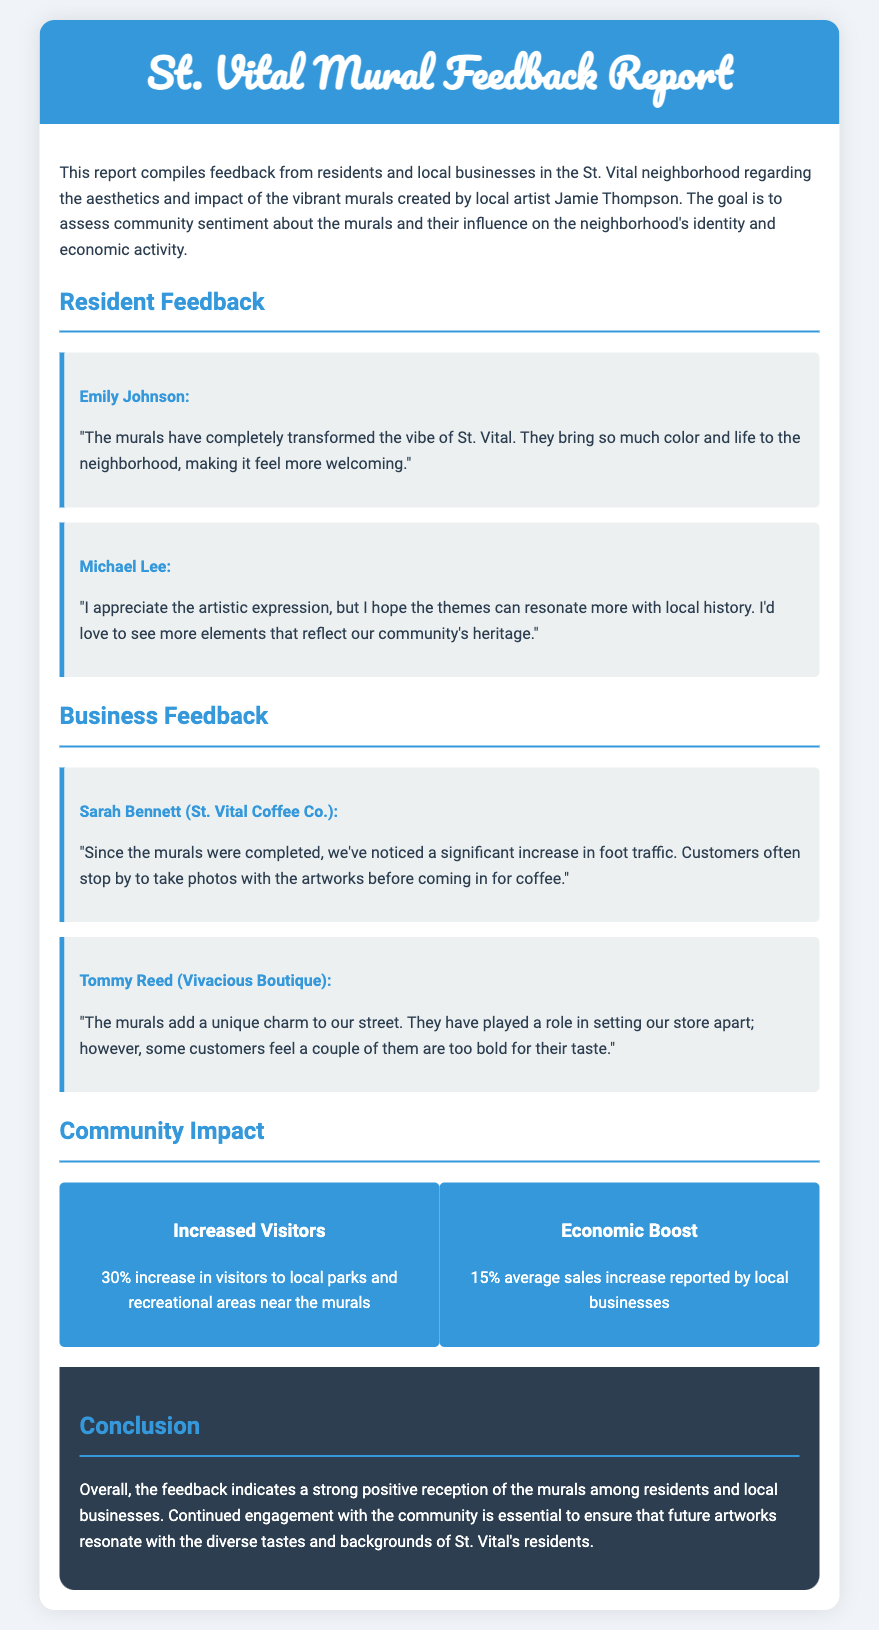what is the name of the local artist? The document states that the local artist responsible for the murals is Jamie Thompson.
Answer: Jamie Thompson how many resident feedback responses are included? There are two resident feedback responses provided in the document.
Answer: 2 what percentage increase in visitors to local parks is mentioned? The report indicates a 30% increase in visitors to local parks and recreational areas near the murals.
Answer: 30% who provided feedback from St. Vital Coffee Co.? Sarah Bennett is the individual who provided feedback from St. Vital Coffee Co.
Answer: Sarah Bennett what is the average sales increase reported by local businesses? The document states that local businesses reported a 15% average sales increase.
Answer: 15% what is Emily Johnson's opinion about the murals? Emily Johnson expresses that the murals have transformed the vibe of St. Vital and made it feel more welcoming.
Answer: Transformed the vibe and made it feel more welcoming which type of shops benefited from the murals according to the feedback? Feedback indicates that local businesses, like coffee shops and boutiques, benefited from the murals.
Answer: Coffee shops and boutiques what is one concern raised by Michael Lee regarding the murals? Michael Lee hopes that the themes of the murals can resonate more with local history.
Answer: Themes resonating more with local history what color is used for the header of the report? The header of the report is colored in a shade of blue, specifically #3498DB.
Answer: Blue what aspect of the community does the conclusion highlight? The conclusion emphasizes the importance of continued engagement with the community for future artworks.
Answer: Continued engagement with the community 